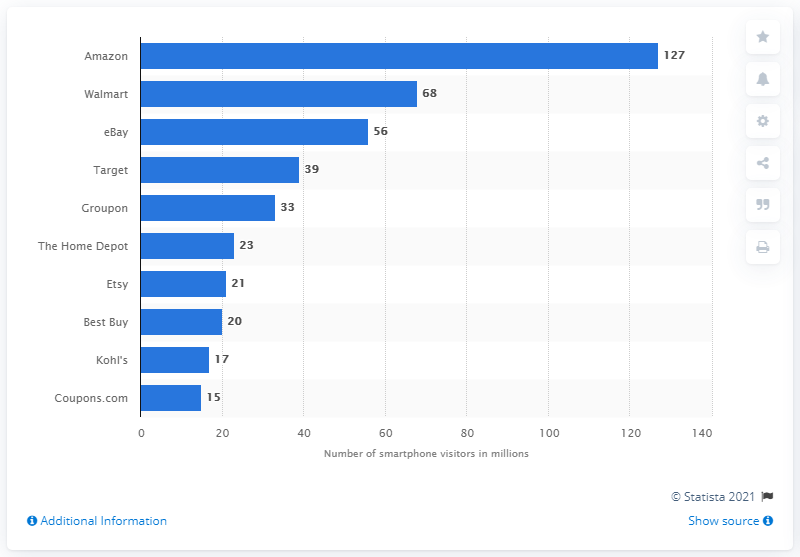Specify some key components in this picture. In September 2018, there were 127 smartphone users who visited Amazon. In September 2018, Walmart was the second most popular mobile retail store in the United States. 